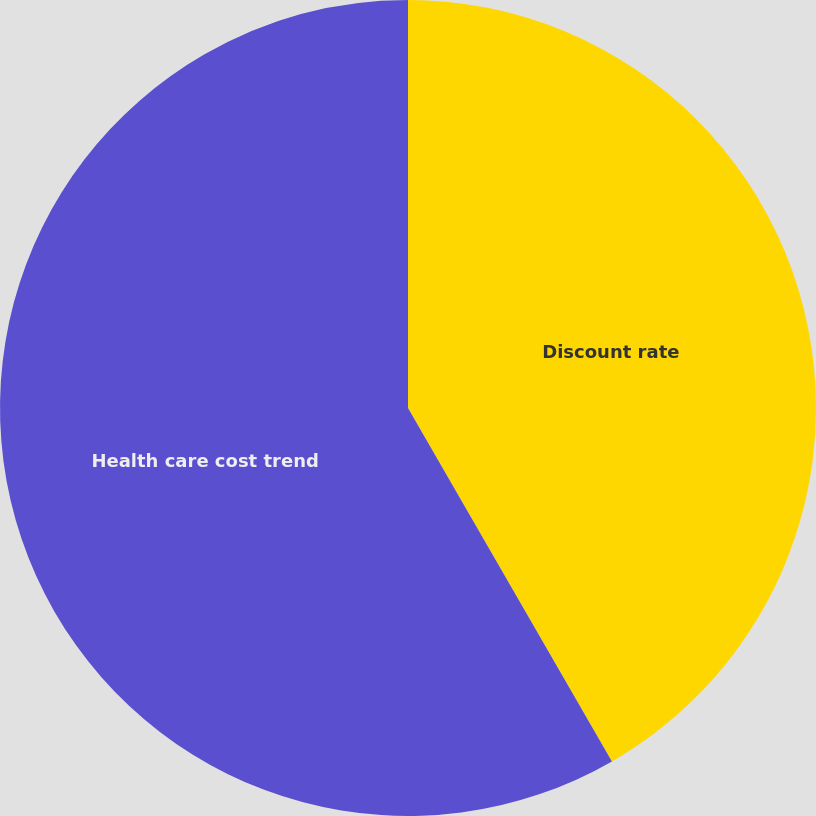Convert chart. <chart><loc_0><loc_0><loc_500><loc_500><pie_chart><fcel>Discount rate<fcel>Health care cost trend<nl><fcel>41.67%<fcel>58.33%<nl></chart> 